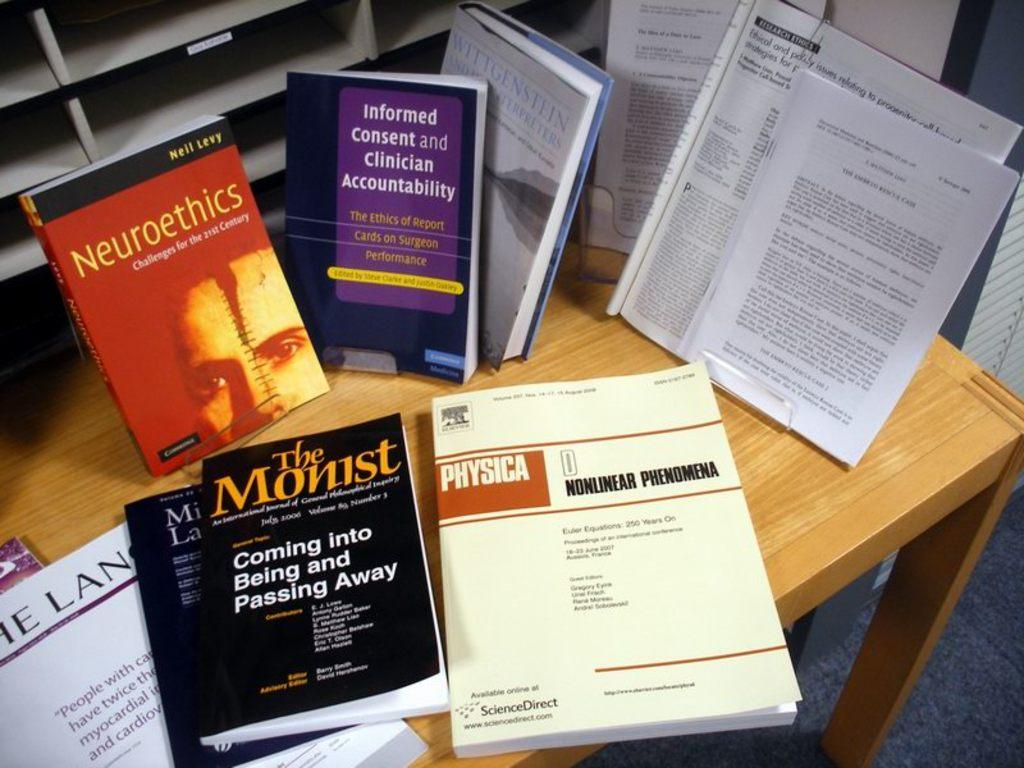Provide a one-sentence caption for the provided image. A table full of text books including a book about nuclear phemomena and another covering coming into being and passing away. 